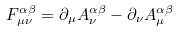Convert formula to latex. <formula><loc_0><loc_0><loc_500><loc_500>F _ { \mu \nu } ^ { \alpha \beta } = \partial _ { \mu } A _ { \nu } ^ { \alpha \beta } - \partial _ { \nu } A _ { \mu } ^ { \alpha \beta }</formula> 